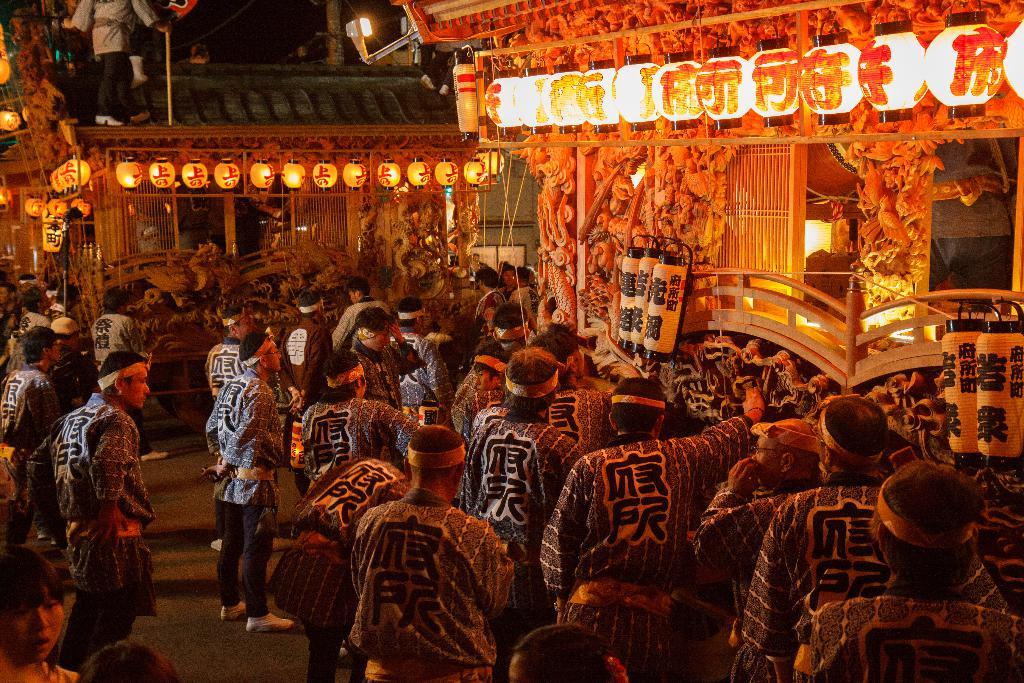What feature do the houses in the image have? The houses in the image have lights and grills. What objects are associated with the houses? There are objects associated with the houses, but the specifics are not mentioned in the facts. What are the people in the image doing? The people in the image are on the road and standing above the house. What type of coat is the porter wearing in the image? There is no porter or coat present in the image. What color is the chalk used to draw on the sidewalk in the image? There is no chalk or drawing on the sidewalk in the image. 